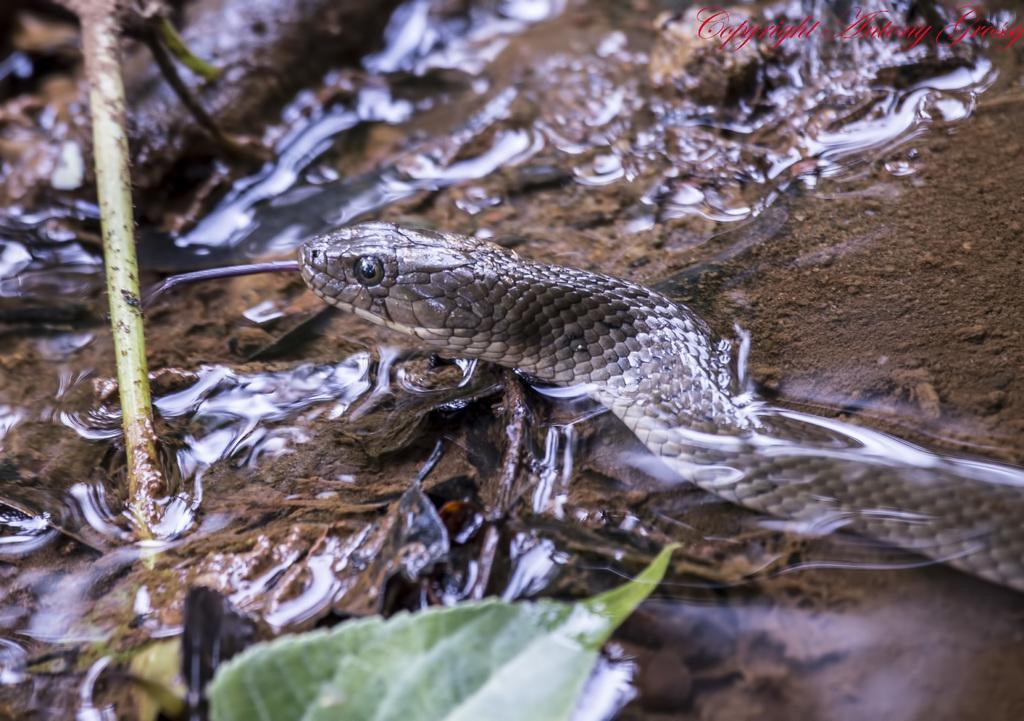In one or two sentences, can you explain what this image depicts? In this image we can see the snake, leaf, stem and also the water. We can also see the soil. In the top right corner we can see the text. 